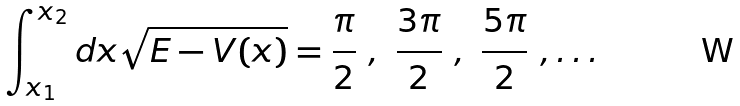<formula> <loc_0><loc_0><loc_500><loc_500>\int _ { x _ { 1 } } ^ { x _ { 2 } } d x \sqrt { E - V ( x ) } = \frac { \pi } { 2 } \ , \ \frac { 3 \pi } { 2 } \ , \ \frac { 5 \pi } { 2 } \ , \dots</formula> 